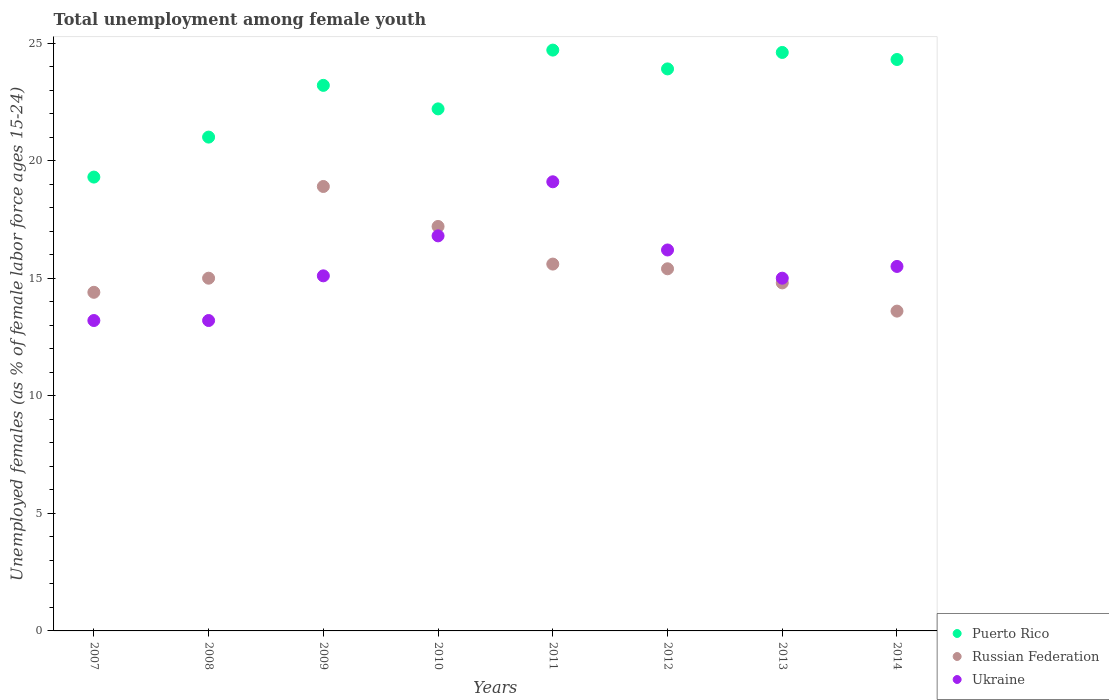What is the percentage of unemployed females in in Ukraine in 2011?
Offer a terse response. 19.1. Across all years, what is the maximum percentage of unemployed females in in Russian Federation?
Ensure brevity in your answer.  18.9. Across all years, what is the minimum percentage of unemployed females in in Ukraine?
Keep it short and to the point. 13.2. In which year was the percentage of unemployed females in in Russian Federation maximum?
Offer a very short reply. 2009. What is the total percentage of unemployed females in in Russian Federation in the graph?
Provide a succinct answer. 124.9. What is the difference between the percentage of unemployed females in in Ukraine in 2009 and that in 2013?
Offer a very short reply. 0.1. What is the difference between the percentage of unemployed females in in Russian Federation in 2013 and the percentage of unemployed females in in Ukraine in 2009?
Your response must be concise. -0.3. What is the average percentage of unemployed females in in Ukraine per year?
Provide a short and direct response. 15.51. In the year 2008, what is the difference between the percentage of unemployed females in in Ukraine and percentage of unemployed females in in Russian Federation?
Provide a succinct answer. -1.8. In how many years, is the percentage of unemployed females in in Russian Federation greater than 22 %?
Your response must be concise. 0. What is the ratio of the percentage of unemployed females in in Puerto Rico in 2010 to that in 2012?
Provide a short and direct response. 0.93. Is the percentage of unemployed females in in Ukraine in 2008 less than that in 2013?
Your response must be concise. Yes. What is the difference between the highest and the second highest percentage of unemployed females in in Russian Federation?
Your response must be concise. 1.7. What is the difference between the highest and the lowest percentage of unemployed females in in Ukraine?
Your answer should be compact. 5.9. Is it the case that in every year, the sum of the percentage of unemployed females in in Russian Federation and percentage of unemployed females in in Ukraine  is greater than the percentage of unemployed females in in Puerto Rico?
Your answer should be compact. Yes. Does the percentage of unemployed females in in Ukraine monotonically increase over the years?
Offer a very short reply. No. Is the percentage of unemployed females in in Ukraine strictly less than the percentage of unemployed females in in Puerto Rico over the years?
Provide a short and direct response. Yes. What is the difference between two consecutive major ticks on the Y-axis?
Provide a succinct answer. 5. Does the graph contain any zero values?
Offer a terse response. No. Does the graph contain grids?
Give a very brief answer. No. What is the title of the graph?
Your response must be concise. Total unemployment among female youth. Does "Mauritania" appear as one of the legend labels in the graph?
Offer a very short reply. No. What is the label or title of the Y-axis?
Provide a short and direct response. Unemployed females (as % of female labor force ages 15-24). What is the Unemployed females (as % of female labor force ages 15-24) of Puerto Rico in 2007?
Offer a terse response. 19.3. What is the Unemployed females (as % of female labor force ages 15-24) in Russian Federation in 2007?
Your answer should be compact. 14.4. What is the Unemployed females (as % of female labor force ages 15-24) in Ukraine in 2007?
Give a very brief answer. 13.2. What is the Unemployed females (as % of female labor force ages 15-24) in Puerto Rico in 2008?
Provide a succinct answer. 21. What is the Unemployed females (as % of female labor force ages 15-24) in Russian Federation in 2008?
Provide a short and direct response. 15. What is the Unemployed females (as % of female labor force ages 15-24) of Ukraine in 2008?
Keep it short and to the point. 13.2. What is the Unemployed females (as % of female labor force ages 15-24) of Puerto Rico in 2009?
Offer a very short reply. 23.2. What is the Unemployed females (as % of female labor force ages 15-24) of Russian Federation in 2009?
Ensure brevity in your answer.  18.9. What is the Unemployed females (as % of female labor force ages 15-24) in Ukraine in 2009?
Provide a short and direct response. 15.1. What is the Unemployed females (as % of female labor force ages 15-24) of Puerto Rico in 2010?
Provide a succinct answer. 22.2. What is the Unemployed females (as % of female labor force ages 15-24) of Russian Federation in 2010?
Your answer should be very brief. 17.2. What is the Unemployed females (as % of female labor force ages 15-24) in Ukraine in 2010?
Provide a short and direct response. 16.8. What is the Unemployed females (as % of female labor force ages 15-24) in Puerto Rico in 2011?
Your answer should be very brief. 24.7. What is the Unemployed females (as % of female labor force ages 15-24) in Russian Federation in 2011?
Your answer should be very brief. 15.6. What is the Unemployed females (as % of female labor force ages 15-24) of Ukraine in 2011?
Your answer should be compact. 19.1. What is the Unemployed females (as % of female labor force ages 15-24) of Puerto Rico in 2012?
Ensure brevity in your answer.  23.9. What is the Unemployed females (as % of female labor force ages 15-24) of Russian Federation in 2012?
Your response must be concise. 15.4. What is the Unemployed females (as % of female labor force ages 15-24) of Ukraine in 2012?
Your response must be concise. 16.2. What is the Unemployed females (as % of female labor force ages 15-24) of Puerto Rico in 2013?
Make the answer very short. 24.6. What is the Unemployed females (as % of female labor force ages 15-24) in Russian Federation in 2013?
Keep it short and to the point. 14.8. What is the Unemployed females (as % of female labor force ages 15-24) in Ukraine in 2013?
Provide a succinct answer. 15. What is the Unemployed females (as % of female labor force ages 15-24) of Puerto Rico in 2014?
Offer a very short reply. 24.3. What is the Unemployed females (as % of female labor force ages 15-24) of Russian Federation in 2014?
Your answer should be compact. 13.6. Across all years, what is the maximum Unemployed females (as % of female labor force ages 15-24) of Puerto Rico?
Your answer should be very brief. 24.7. Across all years, what is the maximum Unemployed females (as % of female labor force ages 15-24) in Russian Federation?
Your response must be concise. 18.9. Across all years, what is the maximum Unemployed females (as % of female labor force ages 15-24) in Ukraine?
Ensure brevity in your answer.  19.1. Across all years, what is the minimum Unemployed females (as % of female labor force ages 15-24) of Puerto Rico?
Provide a succinct answer. 19.3. Across all years, what is the minimum Unemployed females (as % of female labor force ages 15-24) in Russian Federation?
Your answer should be compact. 13.6. Across all years, what is the minimum Unemployed females (as % of female labor force ages 15-24) of Ukraine?
Provide a short and direct response. 13.2. What is the total Unemployed females (as % of female labor force ages 15-24) in Puerto Rico in the graph?
Give a very brief answer. 183.2. What is the total Unemployed females (as % of female labor force ages 15-24) of Russian Federation in the graph?
Offer a very short reply. 124.9. What is the total Unemployed females (as % of female labor force ages 15-24) in Ukraine in the graph?
Give a very brief answer. 124.1. What is the difference between the Unemployed females (as % of female labor force ages 15-24) of Russian Federation in 2007 and that in 2008?
Ensure brevity in your answer.  -0.6. What is the difference between the Unemployed females (as % of female labor force ages 15-24) of Ukraine in 2007 and that in 2008?
Your answer should be very brief. 0. What is the difference between the Unemployed females (as % of female labor force ages 15-24) in Ukraine in 2007 and that in 2009?
Your answer should be compact. -1.9. What is the difference between the Unemployed females (as % of female labor force ages 15-24) of Puerto Rico in 2007 and that in 2010?
Give a very brief answer. -2.9. What is the difference between the Unemployed females (as % of female labor force ages 15-24) of Ukraine in 2007 and that in 2010?
Offer a terse response. -3.6. What is the difference between the Unemployed females (as % of female labor force ages 15-24) in Puerto Rico in 2007 and that in 2011?
Keep it short and to the point. -5.4. What is the difference between the Unemployed females (as % of female labor force ages 15-24) of Ukraine in 2007 and that in 2011?
Give a very brief answer. -5.9. What is the difference between the Unemployed females (as % of female labor force ages 15-24) in Puerto Rico in 2007 and that in 2012?
Offer a very short reply. -4.6. What is the difference between the Unemployed females (as % of female labor force ages 15-24) in Russian Federation in 2007 and that in 2013?
Keep it short and to the point. -0.4. What is the difference between the Unemployed females (as % of female labor force ages 15-24) in Ukraine in 2007 and that in 2013?
Ensure brevity in your answer.  -1.8. What is the difference between the Unemployed females (as % of female labor force ages 15-24) of Ukraine in 2007 and that in 2014?
Make the answer very short. -2.3. What is the difference between the Unemployed females (as % of female labor force ages 15-24) of Puerto Rico in 2008 and that in 2009?
Your response must be concise. -2.2. What is the difference between the Unemployed females (as % of female labor force ages 15-24) of Russian Federation in 2008 and that in 2009?
Keep it short and to the point. -3.9. What is the difference between the Unemployed females (as % of female labor force ages 15-24) in Ukraine in 2008 and that in 2009?
Provide a succinct answer. -1.9. What is the difference between the Unemployed females (as % of female labor force ages 15-24) of Puerto Rico in 2008 and that in 2010?
Your answer should be compact. -1.2. What is the difference between the Unemployed females (as % of female labor force ages 15-24) of Russian Federation in 2008 and that in 2010?
Give a very brief answer. -2.2. What is the difference between the Unemployed females (as % of female labor force ages 15-24) of Russian Federation in 2008 and that in 2011?
Provide a succinct answer. -0.6. What is the difference between the Unemployed females (as % of female labor force ages 15-24) of Puerto Rico in 2008 and that in 2012?
Give a very brief answer. -2.9. What is the difference between the Unemployed females (as % of female labor force ages 15-24) of Russian Federation in 2008 and that in 2012?
Your response must be concise. -0.4. What is the difference between the Unemployed females (as % of female labor force ages 15-24) of Ukraine in 2008 and that in 2012?
Keep it short and to the point. -3. What is the difference between the Unemployed females (as % of female labor force ages 15-24) of Puerto Rico in 2008 and that in 2013?
Keep it short and to the point. -3.6. What is the difference between the Unemployed females (as % of female labor force ages 15-24) of Ukraine in 2008 and that in 2013?
Your response must be concise. -1.8. What is the difference between the Unemployed females (as % of female labor force ages 15-24) of Puerto Rico in 2008 and that in 2014?
Keep it short and to the point. -3.3. What is the difference between the Unemployed females (as % of female labor force ages 15-24) in Russian Federation in 2008 and that in 2014?
Ensure brevity in your answer.  1.4. What is the difference between the Unemployed females (as % of female labor force ages 15-24) in Puerto Rico in 2009 and that in 2011?
Make the answer very short. -1.5. What is the difference between the Unemployed females (as % of female labor force ages 15-24) in Puerto Rico in 2009 and that in 2012?
Give a very brief answer. -0.7. What is the difference between the Unemployed females (as % of female labor force ages 15-24) in Ukraine in 2009 and that in 2012?
Your answer should be very brief. -1.1. What is the difference between the Unemployed females (as % of female labor force ages 15-24) in Ukraine in 2009 and that in 2013?
Provide a short and direct response. 0.1. What is the difference between the Unemployed females (as % of female labor force ages 15-24) of Ukraine in 2009 and that in 2014?
Ensure brevity in your answer.  -0.4. What is the difference between the Unemployed females (as % of female labor force ages 15-24) in Russian Federation in 2010 and that in 2011?
Offer a terse response. 1.6. What is the difference between the Unemployed females (as % of female labor force ages 15-24) of Ukraine in 2010 and that in 2011?
Ensure brevity in your answer.  -2.3. What is the difference between the Unemployed females (as % of female labor force ages 15-24) of Russian Federation in 2010 and that in 2012?
Ensure brevity in your answer.  1.8. What is the difference between the Unemployed females (as % of female labor force ages 15-24) of Puerto Rico in 2010 and that in 2013?
Provide a short and direct response. -2.4. What is the difference between the Unemployed females (as % of female labor force ages 15-24) in Russian Federation in 2010 and that in 2014?
Your answer should be compact. 3.6. What is the difference between the Unemployed females (as % of female labor force ages 15-24) of Russian Federation in 2011 and that in 2012?
Your answer should be compact. 0.2. What is the difference between the Unemployed females (as % of female labor force ages 15-24) in Puerto Rico in 2011 and that in 2013?
Your answer should be very brief. 0.1. What is the difference between the Unemployed females (as % of female labor force ages 15-24) in Russian Federation in 2011 and that in 2013?
Keep it short and to the point. 0.8. What is the difference between the Unemployed females (as % of female labor force ages 15-24) in Puerto Rico in 2011 and that in 2014?
Ensure brevity in your answer.  0.4. What is the difference between the Unemployed females (as % of female labor force ages 15-24) of Ukraine in 2012 and that in 2014?
Ensure brevity in your answer.  0.7. What is the difference between the Unemployed females (as % of female labor force ages 15-24) of Puerto Rico in 2013 and that in 2014?
Offer a very short reply. 0.3. What is the difference between the Unemployed females (as % of female labor force ages 15-24) of Russian Federation in 2013 and that in 2014?
Keep it short and to the point. 1.2. What is the difference between the Unemployed females (as % of female labor force ages 15-24) of Ukraine in 2013 and that in 2014?
Your answer should be compact. -0.5. What is the difference between the Unemployed females (as % of female labor force ages 15-24) in Puerto Rico in 2007 and the Unemployed females (as % of female labor force ages 15-24) in Russian Federation in 2008?
Your answer should be very brief. 4.3. What is the difference between the Unemployed females (as % of female labor force ages 15-24) in Puerto Rico in 2007 and the Unemployed females (as % of female labor force ages 15-24) in Russian Federation in 2009?
Offer a terse response. 0.4. What is the difference between the Unemployed females (as % of female labor force ages 15-24) of Puerto Rico in 2007 and the Unemployed females (as % of female labor force ages 15-24) of Ukraine in 2009?
Your response must be concise. 4.2. What is the difference between the Unemployed females (as % of female labor force ages 15-24) of Russian Federation in 2007 and the Unemployed females (as % of female labor force ages 15-24) of Ukraine in 2009?
Your answer should be very brief. -0.7. What is the difference between the Unemployed females (as % of female labor force ages 15-24) in Russian Federation in 2007 and the Unemployed females (as % of female labor force ages 15-24) in Ukraine in 2010?
Your response must be concise. -2.4. What is the difference between the Unemployed females (as % of female labor force ages 15-24) in Puerto Rico in 2007 and the Unemployed females (as % of female labor force ages 15-24) in Ukraine in 2011?
Keep it short and to the point. 0.2. What is the difference between the Unemployed females (as % of female labor force ages 15-24) of Puerto Rico in 2007 and the Unemployed females (as % of female labor force ages 15-24) of Ukraine in 2012?
Your response must be concise. 3.1. What is the difference between the Unemployed females (as % of female labor force ages 15-24) in Russian Federation in 2007 and the Unemployed females (as % of female labor force ages 15-24) in Ukraine in 2012?
Your answer should be very brief. -1.8. What is the difference between the Unemployed females (as % of female labor force ages 15-24) in Puerto Rico in 2007 and the Unemployed females (as % of female labor force ages 15-24) in Russian Federation in 2013?
Your answer should be very brief. 4.5. What is the difference between the Unemployed females (as % of female labor force ages 15-24) of Puerto Rico in 2007 and the Unemployed females (as % of female labor force ages 15-24) of Ukraine in 2014?
Ensure brevity in your answer.  3.8. What is the difference between the Unemployed females (as % of female labor force ages 15-24) of Russian Federation in 2007 and the Unemployed females (as % of female labor force ages 15-24) of Ukraine in 2014?
Give a very brief answer. -1.1. What is the difference between the Unemployed females (as % of female labor force ages 15-24) in Puerto Rico in 2008 and the Unemployed females (as % of female labor force ages 15-24) in Russian Federation in 2009?
Your answer should be compact. 2.1. What is the difference between the Unemployed females (as % of female labor force ages 15-24) of Puerto Rico in 2008 and the Unemployed females (as % of female labor force ages 15-24) of Ukraine in 2009?
Offer a very short reply. 5.9. What is the difference between the Unemployed females (as % of female labor force ages 15-24) of Puerto Rico in 2008 and the Unemployed females (as % of female labor force ages 15-24) of Ukraine in 2011?
Your answer should be compact. 1.9. What is the difference between the Unemployed females (as % of female labor force ages 15-24) in Puerto Rico in 2008 and the Unemployed females (as % of female labor force ages 15-24) in Ukraine in 2012?
Ensure brevity in your answer.  4.8. What is the difference between the Unemployed females (as % of female labor force ages 15-24) in Puerto Rico in 2008 and the Unemployed females (as % of female labor force ages 15-24) in Russian Federation in 2013?
Provide a succinct answer. 6.2. What is the difference between the Unemployed females (as % of female labor force ages 15-24) in Puerto Rico in 2008 and the Unemployed females (as % of female labor force ages 15-24) in Ukraine in 2013?
Keep it short and to the point. 6. What is the difference between the Unemployed females (as % of female labor force ages 15-24) of Puerto Rico in 2008 and the Unemployed females (as % of female labor force ages 15-24) of Russian Federation in 2014?
Make the answer very short. 7.4. What is the difference between the Unemployed females (as % of female labor force ages 15-24) in Puerto Rico in 2008 and the Unemployed females (as % of female labor force ages 15-24) in Ukraine in 2014?
Offer a terse response. 5.5. What is the difference between the Unemployed females (as % of female labor force ages 15-24) in Puerto Rico in 2009 and the Unemployed females (as % of female labor force ages 15-24) in Ukraine in 2010?
Your answer should be compact. 6.4. What is the difference between the Unemployed females (as % of female labor force ages 15-24) in Russian Federation in 2009 and the Unemployed females (as % of female labor force ages 15-24) in Ukraine in 2010?
Keep it short and to the point. 2.1. What is the difference between the Unemployed females (as % of female labor force ages 15-24) of Puerto Rico in 2009 and the Unemployed females (as % of female labor force ages 15-24) of Ukraine in 2011?
Make the answer very short. 4.1. What is the difference between the Unemployed females (as % of female labor force ages 15-24) of Russian Federation in 2009 and the Unemployed females (as % of female labor force ages 15-24) of Ukraine in 2011?
Your answer should be very brief. -0.2. What is the difference between the Unemployed females (as % of female labor force ages 15-24) of Puerto Rico in 2009 and the Unemployed females (as % of female labor force ages 15-24) of Russian Federation in 2012?
Give a very brief answer. 7.8. What is the difference between the Unemployed females (as % of female labor force ages 15-24) of Puerto Rico in 2009 and the Unemployed females (as % of female labor force ages 15-24) of Ukraine in 2012?
Make the answer very short. 7. What is the difference between the Unemployed females (as % of female labor force ages 15-24) of Puerto Rico in 2009 and the Unemployed females (as % of female labor force ages 15-24) of Ukraine in 2014?
Ensure brevity in your answer.  7.7. What is the difference between the Unemployed females (as % of female labor force ages 15-24) in Puerto Rico in 2010 and the Unemployed females (as % of female labor force ages 15-24) in Ukraine in 2011?
Keep it short and to the point. 3.1. What is the difference between the Unemployed females (as % of female labor force ages 15-24) of Puerto Rico in 2010 and the Unemployed females (as % of female labor force ages 15-24) of Russian Federation in 2012?
Your answer should be compact. 6.8. What is the difference between the Unemployed females (as % of female labor force ages 15-24) of Russian Federation in 2010 and the Unemployed females (as % of female labor force ages 15-24) of Ukraine in 2012?
Provide a succinct answer. 1. What is the difference between the Unemployed females (as % of female labor force ages 15-24) in Puerto Rico in 2010 and the Unemployed females (as % of female labor force ages 15-24) in Ukraine in 2013?
Provide a succinct answer. 7.2. What is the difference between the Unemployed females (as % of female labor force ages 15-24) in Russian Federation in 2010 and the Unemployed females (as % of female labor force ages 15-24) in Ukraine in 2013?
Ensure brevity in your answer.  2.2. What is the difference between the Unemployed females (as % of female labor force ages 15-24) of Puerto Rico in 2010 and the Unemployed females (as % of female labor force ages 15-24) of Russian Federation in 2014?
Provide a short and direct response. 8.6. What is the difference between the Unemployed females (as % of female labor force ages 15-24) in Puerto Rico in 2010 and the Unemployed females (as % of female labor force ages 15-24) in Ukraine in 2014?
Offer a terse response. 6.7. What is the difference between the Unemployed females (as % of female labor force ages 15-24) in Puerto Rico in 2011 and the Unemployed females (as % of female labor force ages 15-24) in Russian Federation in 2012?
Provide a short and direct response. 9.3. What is the difference between the Unemployed females (as % of female labor force ages 15-24) of Puerto Rico in 2011 and the Unemployed females (as % of female labor force ages 15-24) of Ukraine in 2012?
Provide a succinct answer. 8.5. What is the difference between the Unemployed females (as % of female labor force ages 15-24) of Puerto Rico in 2011 and the Unemployed females (as % of female labor force ages 15-24) of Russian Federation in 2013?
Give a very brief answer. 9.9. What is the difference between the Unemployed females (as % of female labor force ages 15-24) in Puerto Rico in 2011 and the Unemployed females (as % of female labor force ages 15-24) in Ukraine in 2013?
Give a very brief answer. 9.7. What is the difference between the Unemployed females (as % of female labor force ages 15-24) in Puerto Rico in 2011 and the Unemployed females (as % of female labor force ages 15-24) in Russian Federation in 2014?
Offer a terse response. 11.1. What is the difference between the Unemployed females (as % of female labor force ages 15-24) in Puerto Rico in 2011 and the Unemployed females (as % of female labor force ages 15-24) in Ukraine in 2014?
Give a very brief answer. 9.2. What is the difference between the Unemployed females (as % of female labor force ages 15-24) of Russian Federation in 2011 and the Unemployed females (as % of female labor force ages 15-24) of Ukraine in 2014?
Provide a succinct answer. 0.1. What is the difference between the Unemployed females (as % of female labor force ages 15-24) in Puerto Rico in 2012 and the Unemployed females (as % of female labor force ages 15-24) in Ukraine in 2013?
Ensure brevity in your answer.  8.9. What is the difference between the Unemployed females (as % of female labor force ages 15-24) of Russian Federation in 2012 and the Unemployed females (as % of female labor force ages 15-24) of Ukraine in 2013?
Give a very brief answer. 0.4. What is the difference between the Unemployed females (as % of female labor force ages 15-24) of Puerto Rico in 2012 and the Unemployed females (as % of female labor force ages 15-24) of Russian Federation in 2014?
Offer a very short reply. 10.3. What is the difference between the Unemployed females (as % of female labor force ages 15-24) in Puerto Rico in 2012 and the Unemployed females (as % of female labor force ages 15-24) in Ukraine in 2014?
Offer a very short reply. 8.4. What is the difference between the Unemployed females (as % of female labor force ages 15-24) in Puerto Rico in 2013 and the Unemployed females (as % of female labor force ages 15-24) in Russian Federation in 2014?
Provide a short and direct response. 11. What is the difference between the Unemployed females (as % of female labor force ages 15-24) in Puerto Rico in 2013 and the Unemployed females (as % of female labor force ages 15-24) in Ukraine in 2014?
Provide a short and direct response. 9.1. What is the average Unemployed females (as % of female labor force ages 15-24) of Puerto Rico per year?
Provide a succinct answer. 22.9. What is the average Unemployed females (as % of female labor force ages 15-24) of Russian Federation per year?
Give a very brief answer. 15.61. What is the average Unemployed females (as % of female labor force ages 15-24) in Ukraine per year?
Offer a very short reply. 15.51. In the year 2007, what is the difference between the Unemployed females (as % of female labor force ages 15-24) of Puerto Rico and Unemployed females (as % of female labor force ages 15-24) of Ukraine?
Keep it short and to the point. 6.1. In the year 2008, what is the difference between the Unemployed females (as % of female labor force ages 15-24) in Puerto Rico and Unemployed females (as % of female labor force ages 15-24) in Ukraine?
Offer a very short reply. 7.8. In the year 2008, what is the difference between the Unemployed females (as % of female labor force ages 15-24) of Russian Federation and Unemployed females (as % of female labor force ages 15-24) of Ukraine?
Your response must be concise. 1.8. In the year 2009, what is the difference between the Unemployed females (as % of female labor force ages 15-24) in Puerto Rico and Unemployed females (as % of female labor force ages 15-24) in Russian Federation?
Your response must be concise. 4.3. In the year 2010, what is the difference between the Unemployed females (as % of female labor force ages 15-24) of Puerto Rico and Unemployed females (as % of female labor force ages 15-24) of Russian Federation?
Your answer should be compact. 5. In the year 2010, what is the difference between the Unemployed females (as % of female labor force ages 15-24) in Puerto Rico and Unemployed females (as % of female labor force ages 15-24) in Ukraine?
Your answer should be very brief. 5.4. In the year 2010, what is the difference between the Unemployed females (as % of female labor force ages 15-24) in Russian Federation and Unemployed females (as % of female labor force ages 15-24) in Ukraine?
Keep it short and to the point. 0.4. In the year 2011, what is the difference between the Unemployed females (as % of female labor force ages 15-24) of Puerto Rico and Unemployed females (as % of female labor force ages 15-24) of Ukraine?
Keep it short and to the point. 5.6. In the year 2011, what is the difference between the Unemployed females (as % of female labor force ages 15-24) in Russian Federation and Unemployed females (as % of female labor force ages 15-24) in Ukraine?
Offer a terse response. -3.5. In the year 2012, what is the difference between the Unemployed females (as % of female labor force ages 15-24) of Puerto Rico and Unemployed females (as % of female labor force ages 15-24) of Russian Federation?
Keep it short and to the point. 8.5. In the year 2012, what is the difference between the Unemployed females (as % of female labor force ages 15-24) of Puerto Rico and Unemployed females (as % of female labor force ages 15-24) of Ukraine?
Provide a short and direct response. 7.7. In the year 2012, what is the difference between the Unemployed females (as % of female labor force ages 15-24) in Russian Federation and Unemployed females (as % of female labor force ages 15-24) in Ukraine?
Your answer should be compact. -0.8. In the year 2013, what is the difference between the Unemployed females (as % of female labor force ages 15-24) in Puerto Rico and Unemployed females (as % of female labor force ages 15-24) in Russian Federation?
Your response must be concise. 9.8. In the year 2013, what is the difference between the Unemployed females (as % of female labor force ages 15-24) of Russian Federation and Unemployed females (as % of female labor force ages 15-24) of Ukraine?
Provide a succinct answer. -0.2. In the year 2014, what is the difference between the Unemployed females (as % of female labor force ages 15-24) in Puerto Rico and Unemployed females (as % of female labor force ages 15-24) in Russian Federation?
Provide a succinct answer. 10.7. In the year 2014, what is the difference between the Unemployed females (as % of female labor force ages 15-24) of Russian Federation and Unemployed females (as % of female labor force ages 15-24) of Ukraine?
Your answer should be compact. -1.9. What is the ratio of the Unemployed females (as % of female labor force ages 15-24) of Puerto Rico in 2007 to that in 2008?
Your answer should be very brief. 0.92. What is the ratio of the Unemployed females (as % of female labor force ages 15-24) of Russian Federation in 2007 to that in 2008?
Give a very brief answer. 0.96. What is the ratio of the Unemployed females (as % of female labor force ages 15-24) in Ukraine in 2007 to that in 2008?
Make the answer very short. 1. What is the ratio of the Unemployed females (as % of female labor force ages 15-24) of Puerto Rico in 2007 to that in 2009?
Offer a very short reply. 0.83. What is the ratio of the Unemployed females (as % of female labor force ages 15-24) of Russian Federation in 2007 to that in 2009?
Keep it short and to the point. 0.76. What is the ratio of the Unemployed females (as % of female labor force ages 15-24) in Ukraine in 2007 to that in 2009?
Offer a terse response. 0.87. What is the ratio of the Unemployed females (as % of female labor force ages 15-24) in Puerto Rico in 2007 to that in 2010?
Ensure brevity in your answer.  0.87. What is the ratio of the Unemployed females (as % of female labor force ages 15-24) of Russian Federation in 2007 to that in 2010?
Ensure brevity in your answer.  0.84. What is the ratio of the Unemployed females (as % of female labor force ages 15-24) in Ukraine in 2007 to that in 2010?
Your answer should be very brief. 0.79. What is the ratio of the Unemployed females (as % of female labor force ages 15-24) in Puerto Rico in 2007 to that in 2011?
Give a very brief answer. 0.78. What is the ratio of the Unemployed females (as % of female labor force ages 15-24) of Ukraine in 2007 to that in 2011?
Make the answer very short. 0.69. What is the ratio of the Unemployed females (as % of female labor force ages 15-24) of Puerto Rico in 2007 to that in 2012?
Provide a short and direct response. 0.81. What is the ratio of the Unemployed females (as % of female labor force ages 15-24) of Russian Federation in 2007 to that in 2012?
Offer a very short reply. 0.94. What is the ratio of the Unemployed females (as % of female labor force ages 15-24) of Ukraine in 2007 to that in 2012?
Give a very brief answer. 0.81. What is the ratio of the Unemployed females (as % of female labor force ages 15-24) of Puerto Rico in 2007 to that in 2013?
Make the answer very short. 0.78. What is the ratio of the Unemployed females (as % of female labor force ages 15-24) of Ukraine in 2007 to that in 2013?
Ensure brevity in your answer.  0.88. What is the ratio of the Unemployed females (as % of female labor force ages 15-24) of Puerto Rico in 2007 to that in 2014?
Keep it short and to the point. 0.79. What is the ratio of the Unemployed females (as % of female labor force ages 15-24) of Russian Federation in 2007 to that in 2014?
Offer a very short reply. 1.06. What is the ratio of the Unemployed females (as % of female labor force ages 15-24) in Ukraine in 2007 to that in 2014?
Give a very brief answer. 0.85. What is the ratio of the Unemployed females (as % of female labor force ages 15-24) of Puerto Rico in 2008 to that in 2009?
Your response must be concise. 0.91. What is the ratio of the Unemployed females (as % of female labor force ages 15-24) of Russian Federation in 2008 to that in 2009?
Make the answer very short. 0.79. What is the ratio of the Unemployed females (as % of female labor force ages 15-24) of Ukraine in 2008 to that in 2009?
Provide a short and direct response. 0.87. What is the ratio of the Unemployed females (as % of female labor force ages 15-24) of Puerto Rico in 2008 to that in 2010?
Your response must be concise. 0.95. What is the ratio of the Unemployed females (as % of female labor force ages 15-24) of Russian Federation in 2008 to that in 2010?
Give a very brief answer. 0.87. What is the ratio of the Unemployed females (as % of female labor force ages 15-24) of Ukraine in 2008 to that in 2010?
Provide a succinct answer. 0.79. What is the ratio of the Unemployed females (as % of female labor force ages 15-24) of Puerto Rico in 2008 to that in 2011?
Provide a short and direct response. 0.85. What is the ratio of the Unemployed females (as % of female labor force ages 15-24) in Russian Federation in 2008 to that in 2011?
Your answer should be compact. 0.96. What is the ratio of the Unemployed females (as % of female labor force ages 15-24) of Ukraine in 2008 to that in 2011?
Make the answer very short. 0.69. What is the ratio of the Unemployed females (as % of female labor force ages 15-24) in Puerto Rico in 2008 to that in 2012?
Your response must be concise. 0.88. What is the ratio of the Unemployed females (as % of female labor force ages 15-24) in Russian Federation in 2008 to that in 2012?
Your answer should be very brief. 0.97. What is the ratio of the Unemployed females (as % of female labor force ages 15-24) in Ukraine in 2008 to that in 2012?
Offer a very short reply. 0.81. What is the ratio of the Unemployed females (as % of female labor force ages 15-24) of Puerto Rico in 2008 to that in 2013?
Provide a short and direct response. 0.85. What is the ratio of the Unemployed females (as % of female labor force ages 15-24) in Russian Federation in 2008 to that in 2013?
Make the answer very short. 1.01. What is the ratio of the Unemployed females (as % of female labor force ages 15-24) of Puerto Rico in 2008 to that in 2014?
Your response must be concise. 0.86. What is the ratio of the Unemployed females (as % of female labor force ages 15-24) of Russian Federation in 2008 to that in 2014?
Offer a very short reply. 1.1. What is the ratio of the Unemployed females (as % of female labor force ages 15-24) in Ukraine in 2008 to that in 2014?
Your answer should be very brief. 0.85. What is the ratio of the Unemployed females (as % of female labor force ages 15-24) in Puerto Rico in 2009 to that in 2010?
Keep it short and to the point. 1.04. What is the ratio of the Unemployed females (as % of female labor force ages 15-24) of Russian Federation in 2009 to that in 2010?
Your answer should be very brief. 1.1. What is the ratio of the Unemployed females (as % of female labor force ages 15-24) in Ukraine in 2009 to that in 2010?
Offer a terse response. 0.9. What is the ratio of the Unemployed females (as % of female labor force ages 15-24) in Puerto Rico in 2009 to that in 2011?
Provide a short and direct response. 0.94. What is the ratio of the Unemployed females (as % of female labor force ages 15-24) of Russian Federation in 2009 to that in 2011?
Provide a succinct answer. 1.21. What is the ratio of the Unemployed females (as % of female labor force ages 15-24) of Ukraine in 2009 to that in 2011?
Make the answer very short. 0.79. What is the ratio of the Unemployed females (as % of female labor force ages 15-24) in Puerto Rico in 2009 to that in 2012?
Your response must be concise. 0.97. What is the ratio of the Unemployed females (as % of female labor force ages 15-24) in Russian Federation in 2009 to that in 2012?
Your response must be concise. 1.23. What is the ratio of the Unemployed females (as % of female labor force ages 15-24) of Ukraine in 2009 to that in 2012?
Provide a short and direct response. 0.93. What is the ratio of the Unemployed females (as % of female labor force ages 15-24) of Puerto Rico in 2009 to that in 2013?
Your answer should be compact. 0.94. What is the ratio of the Unemployed females (as % of female labor force ages 15-24) in Russian Federation in 2009 to that in 2013?
Provide a succinct answer. 1.28. What is the ratio of the Unemployed females (as % of female labor force ages 15-24) in Puerto Rico in 2009 to that in 2014?
Your response must be concise. 0.95. What is the ratio of the Unemployed females (as % of female labor force ages 15-24) in Russian Federation in 2009 to that in 2014?
Make the answer very short. 1.39. What is the ratio of the Unemployed females (as % of female labor force ages 15-24) of Ukraine in 2009 to that in 2014?
Your answer should be compact. 0.97. What is the ratio of the Unemployed females (as % of female labor force ages 15-24) of Puerto Rico in 2010 to that in 2011?
Provide a succinct answer. 0.9. What is the ratio of the Unemployed females (as % of female labor force ages 15-24) of Russian Federation in 2010 to that in 2011?
Offer a very short reply. 1.1. What is the ratio of the Unemployed females (as % of female labor force ages 15-24) of Ukraine in 2010 to that in 2011?
Ensure brevity in your answer.  0.88. What is the ratio of the Unemployed females (as % of female labor force ages 15-24) of Puerto Rico in 2010 to that in 2012?
Offer a terse response. 0.93. What is the ratio of the Unemployed females (as % of female labor force ages 15-24) in Russian Federation in 2010 to that in 2012?
Give a very brief answer. 1.12. What is the ratio of the Unemployed females (as % of female labor force ages 15-24) of Puerto Rico in 2010 to that in 2013?
Offer a terse response. 0.9. What is the ratio of the Unemployed females (as % of female labor force ages 15-24) of Russian Federation in 2010 to that in 2013?
Provide a succinct answer. 1.16. What is the ratio of the Unemployed females (as % of female labor force ages 15-24) in Ukraine in 2010 to that in 2013?
Offer a terse response. 1.12. What is the ratio of the Unemployed females (as % of female labor force ages 15-24) of Puerto Rico in 2010 to that in 2014?
Provide a short and direct response. 0.91. What is the ratio of the Unemployed females (as % of female labor force ages 15-24) of Russian Federation in 2010 to that in 2014?
Provide a succinct answer. 1.26. What is the ratio of the Unemployed females (as % of female labor force ages 15-24) in Ukraine in 2010 to that in 2014?
Make the answer very short. 1.08. What is the ratio of the Unemployed females (as % of female labor force ages 15-24) in Puerto Rico in 2011 to that in 2012?
Offer a very short reply. 1.03. What is the ratio of the Unemployed females (as % of female labor force ages 15-24) of Russian Federation in 2011 to that in 2012?
Your response must be concise. 1.01. What is the ratio of the Unemployed females (as % of female labor force ages 15-24) in Ukraine in 2011 to that in 2012?
Provide a short and direct response. 1.18. What is the ratio of the Unemployed females (as % of female labor force ages 15-24) of Puerto Rico in 2011 to that in 2013?
Keep it short and to the point. 1. What is the ratio of the Unemployed females (as % of female labor force ages 15-24) in Russian Federation in 2011 to that in 2013?
Ensure brevity in your answer.  1.05. What is the ratio of the Unemployed females (as % of female labor force ages 15-24) of Ukraine in 2011 to that in 2013?
Keep it short and to the point. 1.27. What is the ratio of the Unemployed females (as % of female labor force ages 15-24) in Puerto Rico in 2011 to that in 2014?
Offer a terse response. 1.02. What is the ratio of the Unemployed females (as % of female labor force ages 15-24) in Russian Federation in 2011 to that in 2014?
Make the answer very short. 1.15. What is the ratio of the Unemployed females (as % of female labor force ages 15-24) in Ukraine in 2011 to that in 2014?
Your answer should be very brief. 1.23. What is the ratio of the Unemployed females (as % of female labor force ages 15-24) in Puerto Rico in 2012 to that in 2013?
Provide a succinct answer. 0.97. What is the ratio of the Unemployed females (as % of female labor force ages 15-24) in Russian Federation in 2012 to that in 2013?
Provide a succinct answer. 1.04. What is the ratio of the Unemployed females (as % of female labor force ages 15-24) of Ukraine in 2012 to that in 2013?
Offer a very short reply. 1.08. What is the ratio of the Unemployed females (as % of female labor force ages 15-24) in Puerto Rico in 2012 to that in 2014?
Offer a terse response. 0.98. What is the ratio of the Unemployed females (as % of female labor force ages 15-24) in Russian Federation in 2012 to that in 2014?
Provide a succinct answer. 1.13. What is the ratio of the Unemployed females (as % of female labor force ages 15-24) in Ukraine in 2012 to that in 2014?
Offer a terse response. 1.05. What is the ratio of the Unemployed females (as % of female labor force ages 15-24) of Puerto Rico in 2013 to that in 2014?
Your response must be concise. 1.01. What is the ratio of the Unemployed females (as % of female labor force ages 15-24) of Russian Federation in 2013 to that in 2014?
Offer a very short reply. 1.09. What is the ratio of the Unemployed females (as % of female labor force ages 15-24) of Ukraine in 2013 to that in 2014?
Keep it short and to the point. 0.97. What is the difference between the highest and the second highest Unemployed females (as % of female labor force ages 15-24) in Puerto Rico?
Your answer should be compact. 0.1. What is the difference between the highest and the second highest Unemployed females (as % of female labor force ages 15-24) in Russian Federation?
Offer a very short reply. 1.7. What is the difference between the highest and the lowest Unemployed females (as % of female labor force ages 15-24) of Russian Federation?
Offer a terse response. 5.3. What is the difference between the highest and the lowest Unemployed females (as % of female labor force ages 15-24) in Ukraine?
Keep it short and to the point. 5.9. 